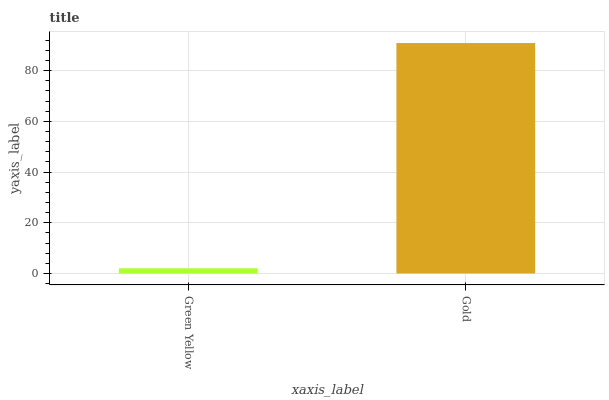Is Gold the minimum?
Answer yes or no. No. Is Gold greater than Green Yellow?
Answer yes or no. Yes. Is Green Yellow less than Gold?
Answer yes or no. Yes. Is Green Yellow greater than Gold?
Answer yes or no. No. Is Gold less than Green Yellow?
Answer yes or no. No. Is Gold the high median?
Answer yes or no. Yes. Is Green Yellow the low median?
Answer yes or no. Yes. Is Green Yellow the high median?
Answer yes or no. No. Is Gold the low median?
Answer yes or no. No. 